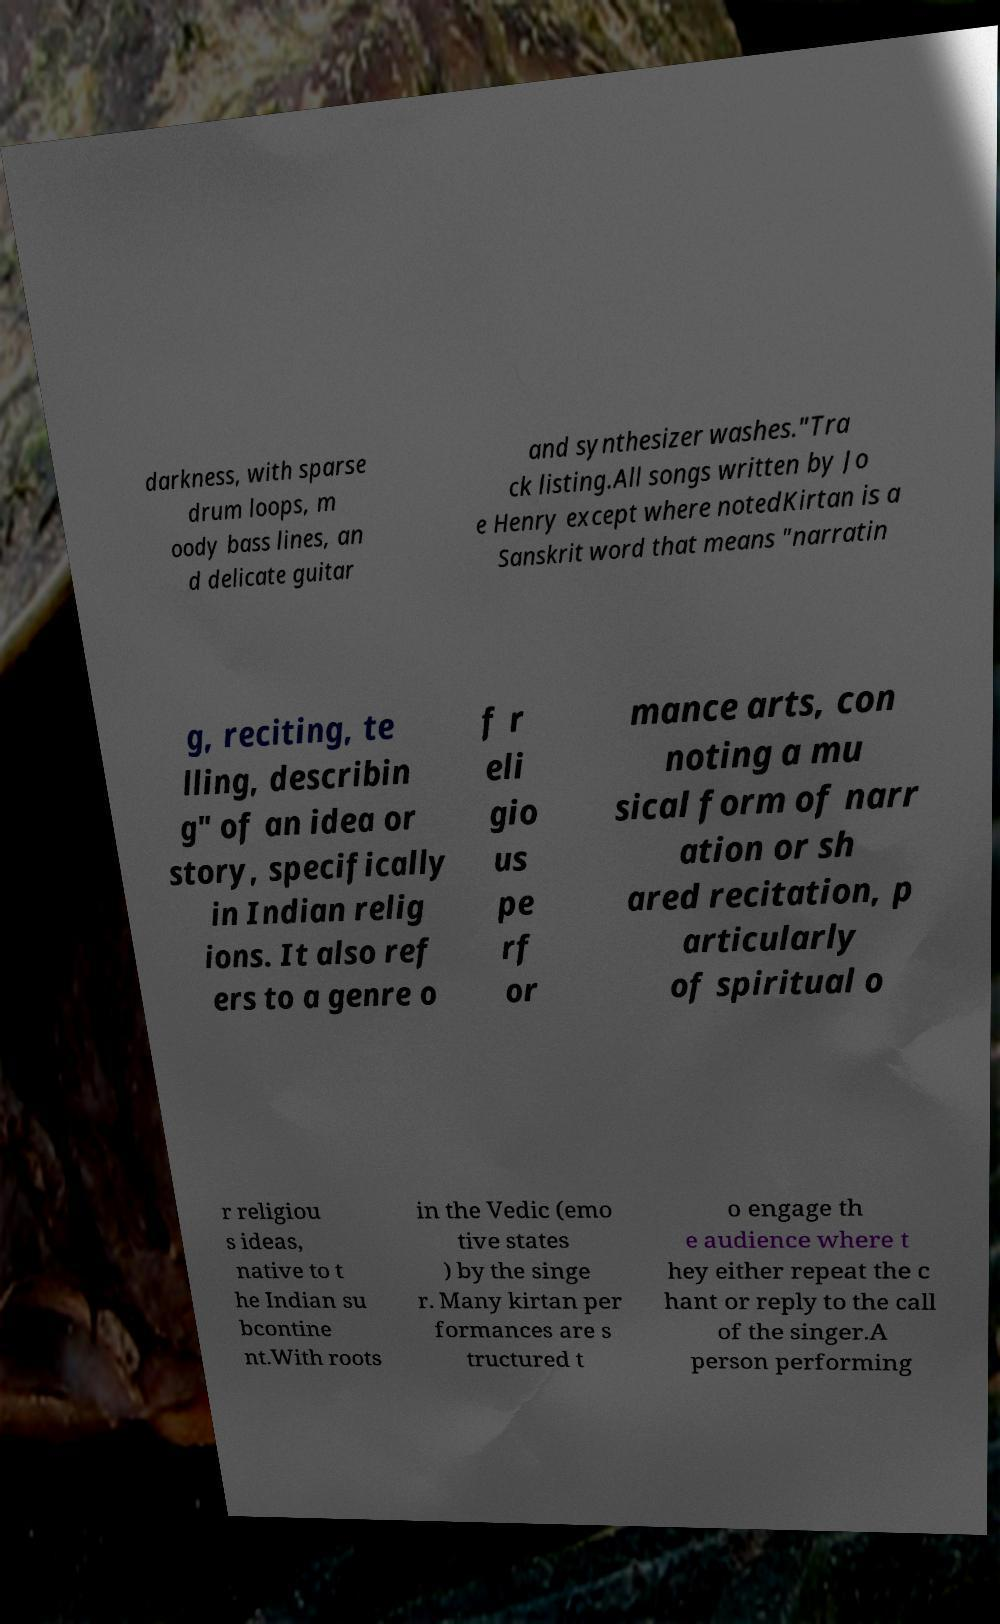Can you accurately transcribe the text from the provided image for me? darkness, with sparse drum loops, m oody bass lines, an d delicate guitar and synthesizer washes."Tra ck listing.All songs written by Jo e Henry except where notedKirtan is a Sanskrit word that means "narratin g, reciting, te lling, describin g" of an idea or story, specifically in Indian relig ions. It also ref ers to a genre o f r eli gio us pe rf or mance arts, con noting a mu sical form of narr ation or sh ared recitation, p articularly of spiritual o r religiou s ideas, native to t he Indian su bcontine nt.With roots in the Vedic (emo tive states ) by the singe r. Many kirtan per formances are s tructured t o engage th e audience where t hey either repeat the c hant or reply to the call of the singer.A person performing 